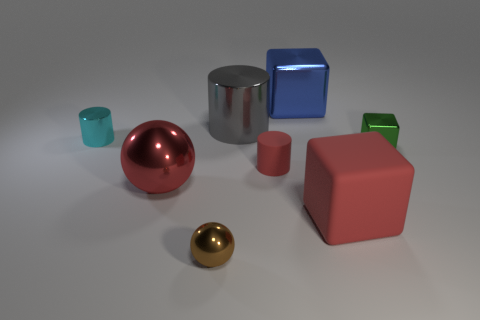Subtract all blue balls. Subtract all yellow cubes. How many balls are left? 2 Add 1 tiny shiny cylinders. How many objects exist? 9 Subtract all cubes. How many objects are left? 5 Add 3 rubber cubes. How many rubber cubes exist? 4 Subtract 0 yellow cylinders. How many objects are left? 8 Subtract all small green spheres. Subtract all large rubber cubes. How many objects are left? 7 Add 6 large red metal objects. How many large red metal objects are left? 7 